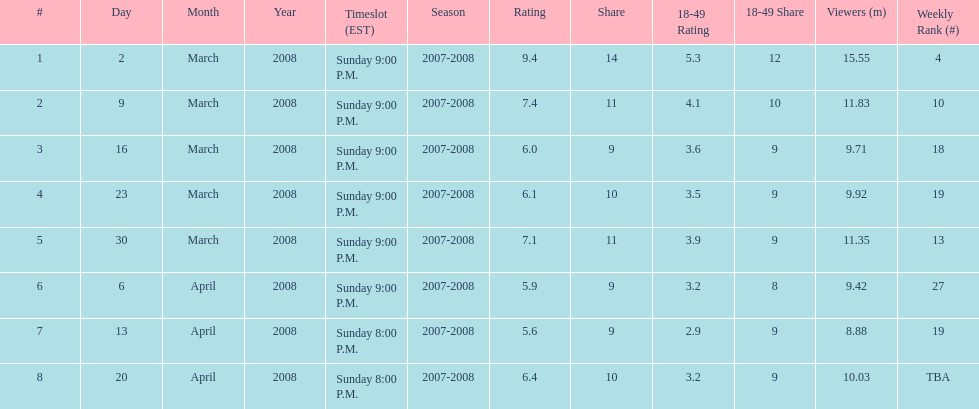What time slot did the show have for its first 6 episodes? Sunday 9:00 P.M. 